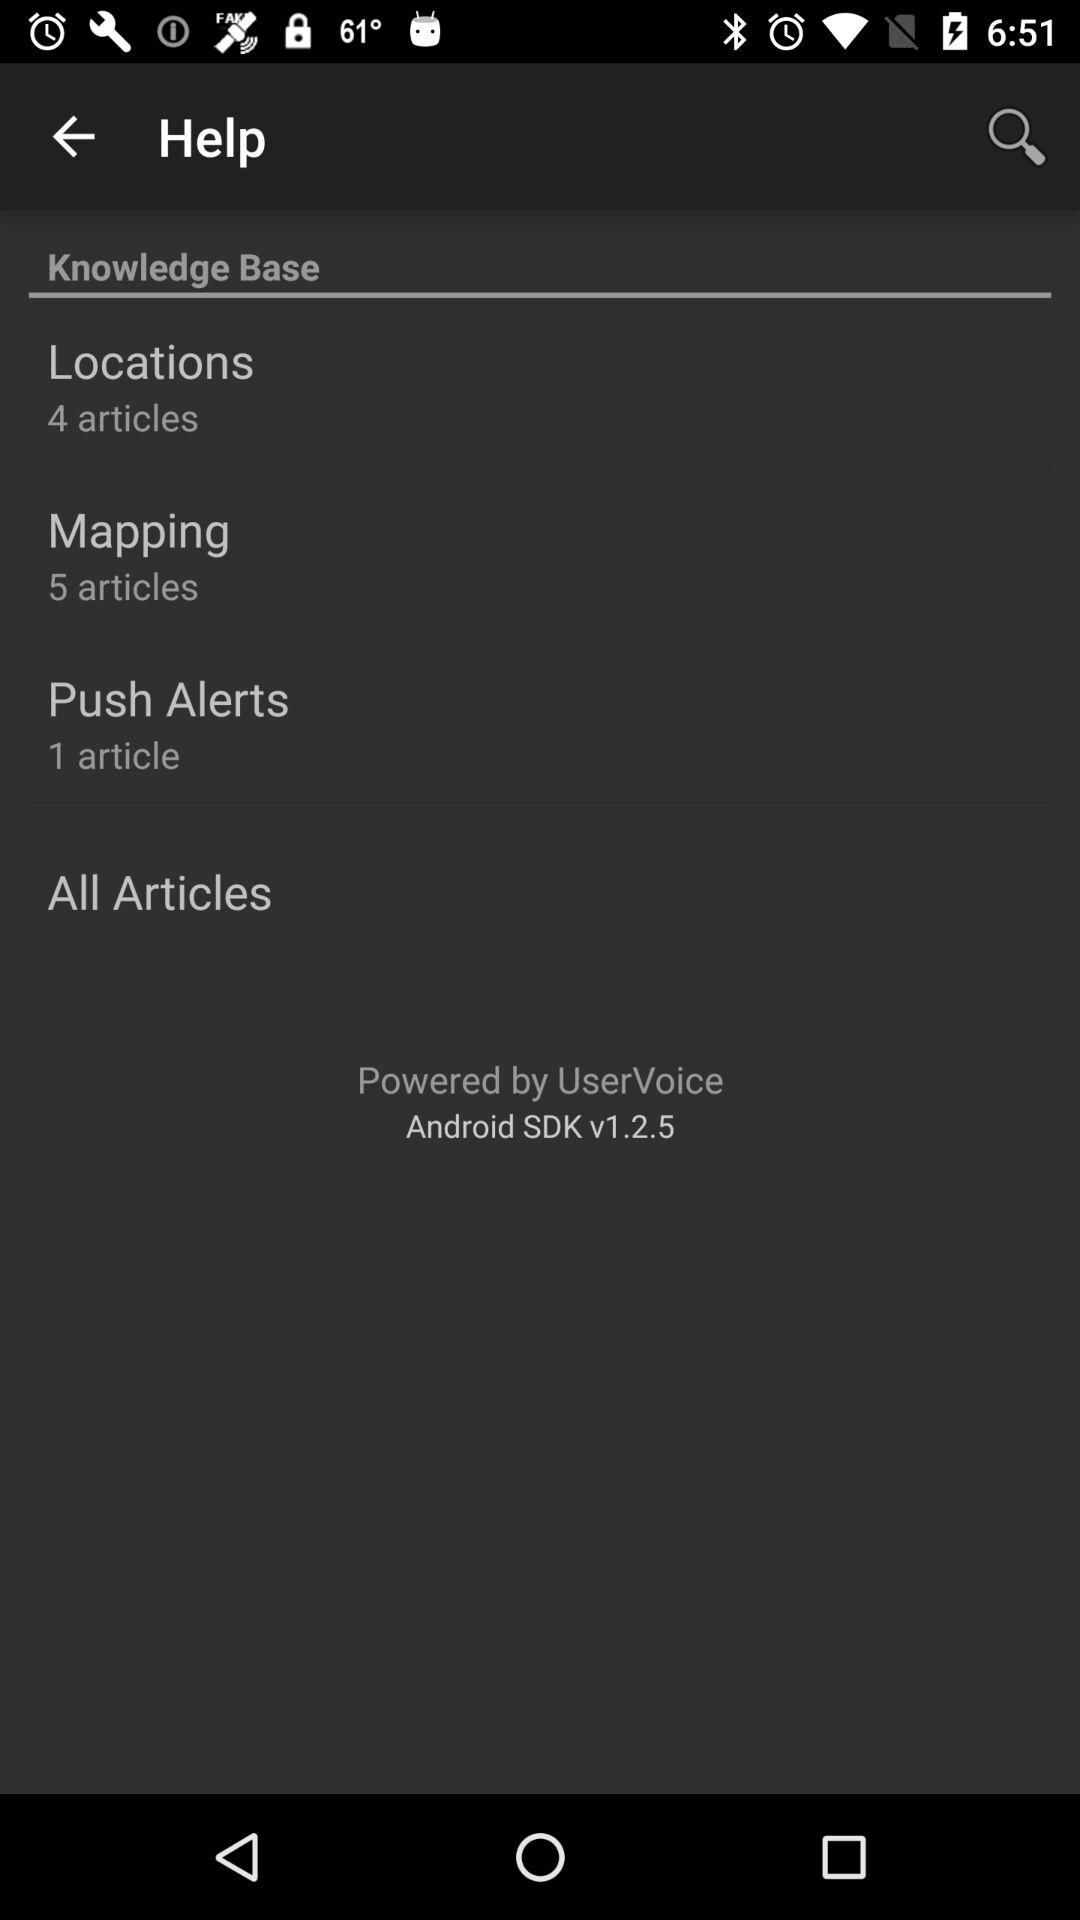What is the version of the application? The version of the application is v1.2.5. 